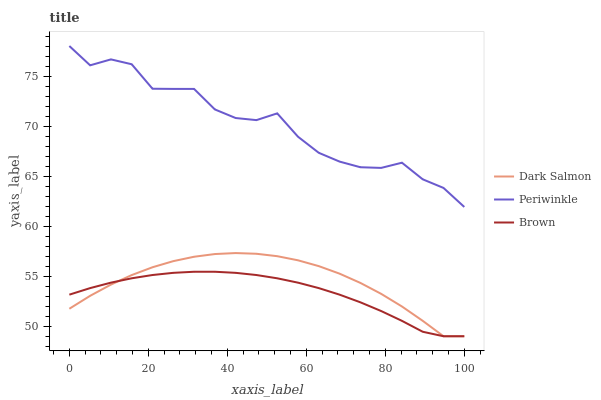Does Brown have the minimum area under the curve?
Answer yes or no. Yes. Does Periwinkle have the maximum area under the curve?
Answer yes or no. Yes. Does Dark Salmon have the minimum area under the curve?
Answer yes or no. No. Does Dark Salmon have the maximum area under the curve?
Answer yes or no. No. Is Brown the smoothest?
Answer yes or no. Yes. Is Periwinkle the roughest?
Answer yes or no. Yes. Is Dark Salmon the smoothest?
Answer yes or no. No. Is Dark Salmon the roughest?
Answer yes or no. No. Does Periwinkle have the lowest value?
Answer yes or no. No. Does Periwinkle have the highest value?
Answer yes or no. Yes. Does Dark Salmon have the highest value?
Answer yes or no. No. Is Dark Salmon less than Periwinkle?
Answer yes or no. Yes. Is Periwinkle greater than Dark Salmon?
Answer yes or no. Yes. Does Brown intersect Dark Salmon?
Answer yes or no. Yes. Is Brown less than Dark Salmon?
Answer yes or no. No. Is Brown greater than Dark Salmon?
Answer yes or no. No. Does Dark Salmon intersect Periwinkle?
Answer yes or no. No. 